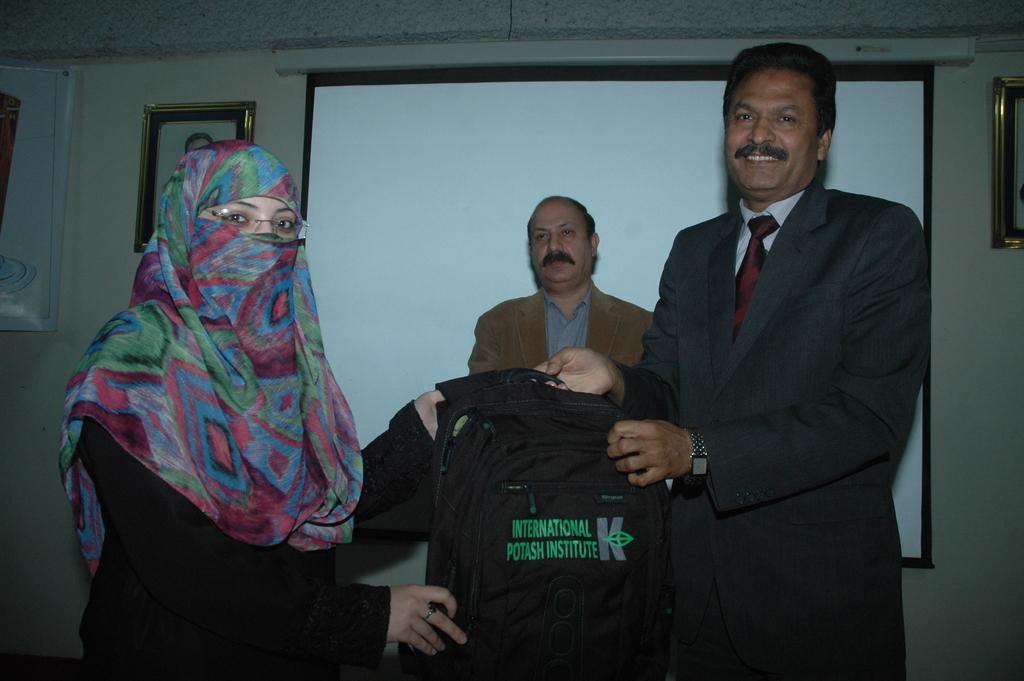Can you describe this image briefly? In the picture I can see a man on the right side is wearing a suit and tie. He is holding a bag and there is a smile on his face. There is a woman on the left side and there is a scarf on her face. In the background, I can see a man wearing a suit. I can see the screen and there are photo frames on the wall. I can see the banner on the top left side. 